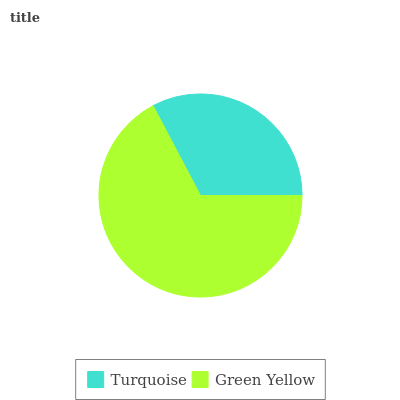Is Turquoise the minimum?
Answer yes or no. Yes. Is Green Yellow the maximum?
Answer yes or no. Yes. Is Green Yellow the minimum?
Answer yes or no. No. Is Green Yellow greater than Turquoise?
Answer yes or no. Yes. Is Turquoise less than Green Yellow?
Answer yes or no. Yes. Is Turquoise greater than Green Yellow?
Answer yes or no. No. Is Green Yellow less than Turquoise?
Answer yes or no. No. Is Green Yellow the high median?
Answer yes or no. Yes. Is Turquoise the low median?
Answer yes or no. Yes. Is Turquoise the high median?
Answer yes or no. No. Is Green Yellow the low median?
Answer yes or no. No. 